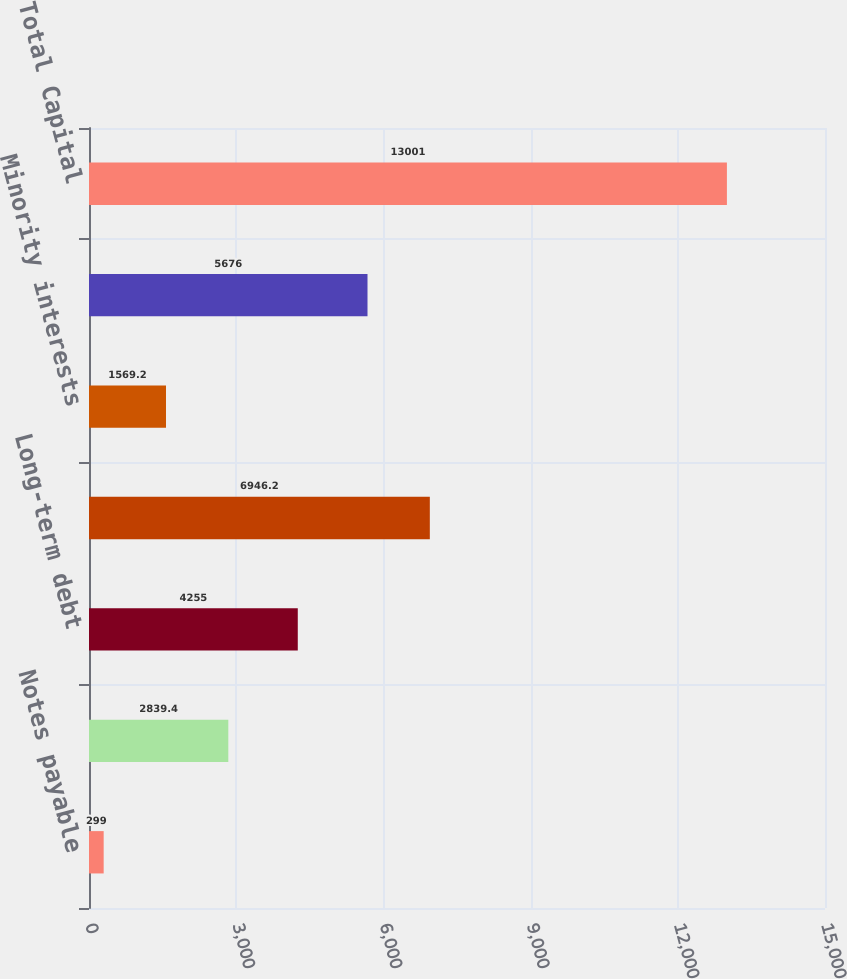Convert chart. <chart><loc_0><loc_0><loc_500><loc_500><bar_chart><fcel>Notes payable<fcel>Current portion of long-term<fcel>Long-term debt<fcel>Total debt<fcel>Minority interests<fcel>Stockholders ' equity<fcel>Total Capital<nl><fcel>299<fcel>2839.4<fcel>4255<fcel>6946.2<fcel>1569.2<fcel>5676<fcel>13001<nl></chart> 